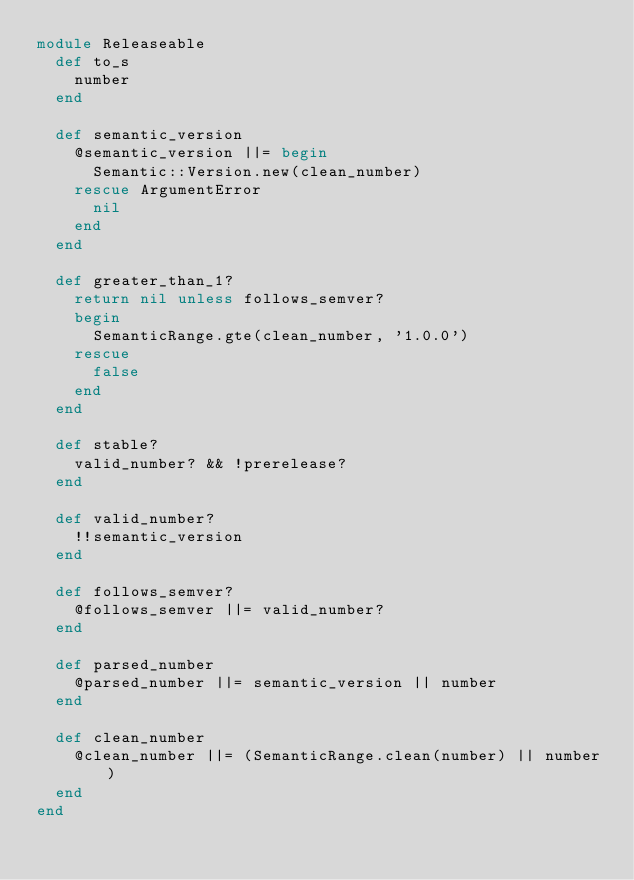<code> <loc_0><loc_0><loc_500><loc_500><_Ruby_>module Releaseable
  def to_s
    number
  end

  def semantic_version
    @semantic_version ||= begin
      Semantic::Version.new(clean_number)
    rescue ArgumentError
      nil
    end
  end

  def greater_than_1?
    return nil unless follows_semver?
    begin
      SemanticRange.gte(clean_number, '1.0.0')
    rescue
      false
    end
  end

  def stable?
    valid_number? && !prerelease?
  end

  def valid_number?
    !!semantic_version
  end

  def follows_semver?
    @follows_semver ||= valid_number?
  end

  def parsed_number
    @parsed_number ||= semantic_version || number
  end

  def clean_number
    @clean_number ||= (SemanticRange.clean(number) || number)
  end
end
</code> 